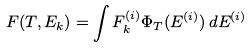Convert formula to latex. <formula><loc_0><loc_0><loc_500><loc_500>F ( T , E _ { k } ) = \int F _ { k } ^ { ( i ) } \Phi _ { T } ( E ^ { ( i ) } ) \, d E ^ { ( i ) }</formula> 